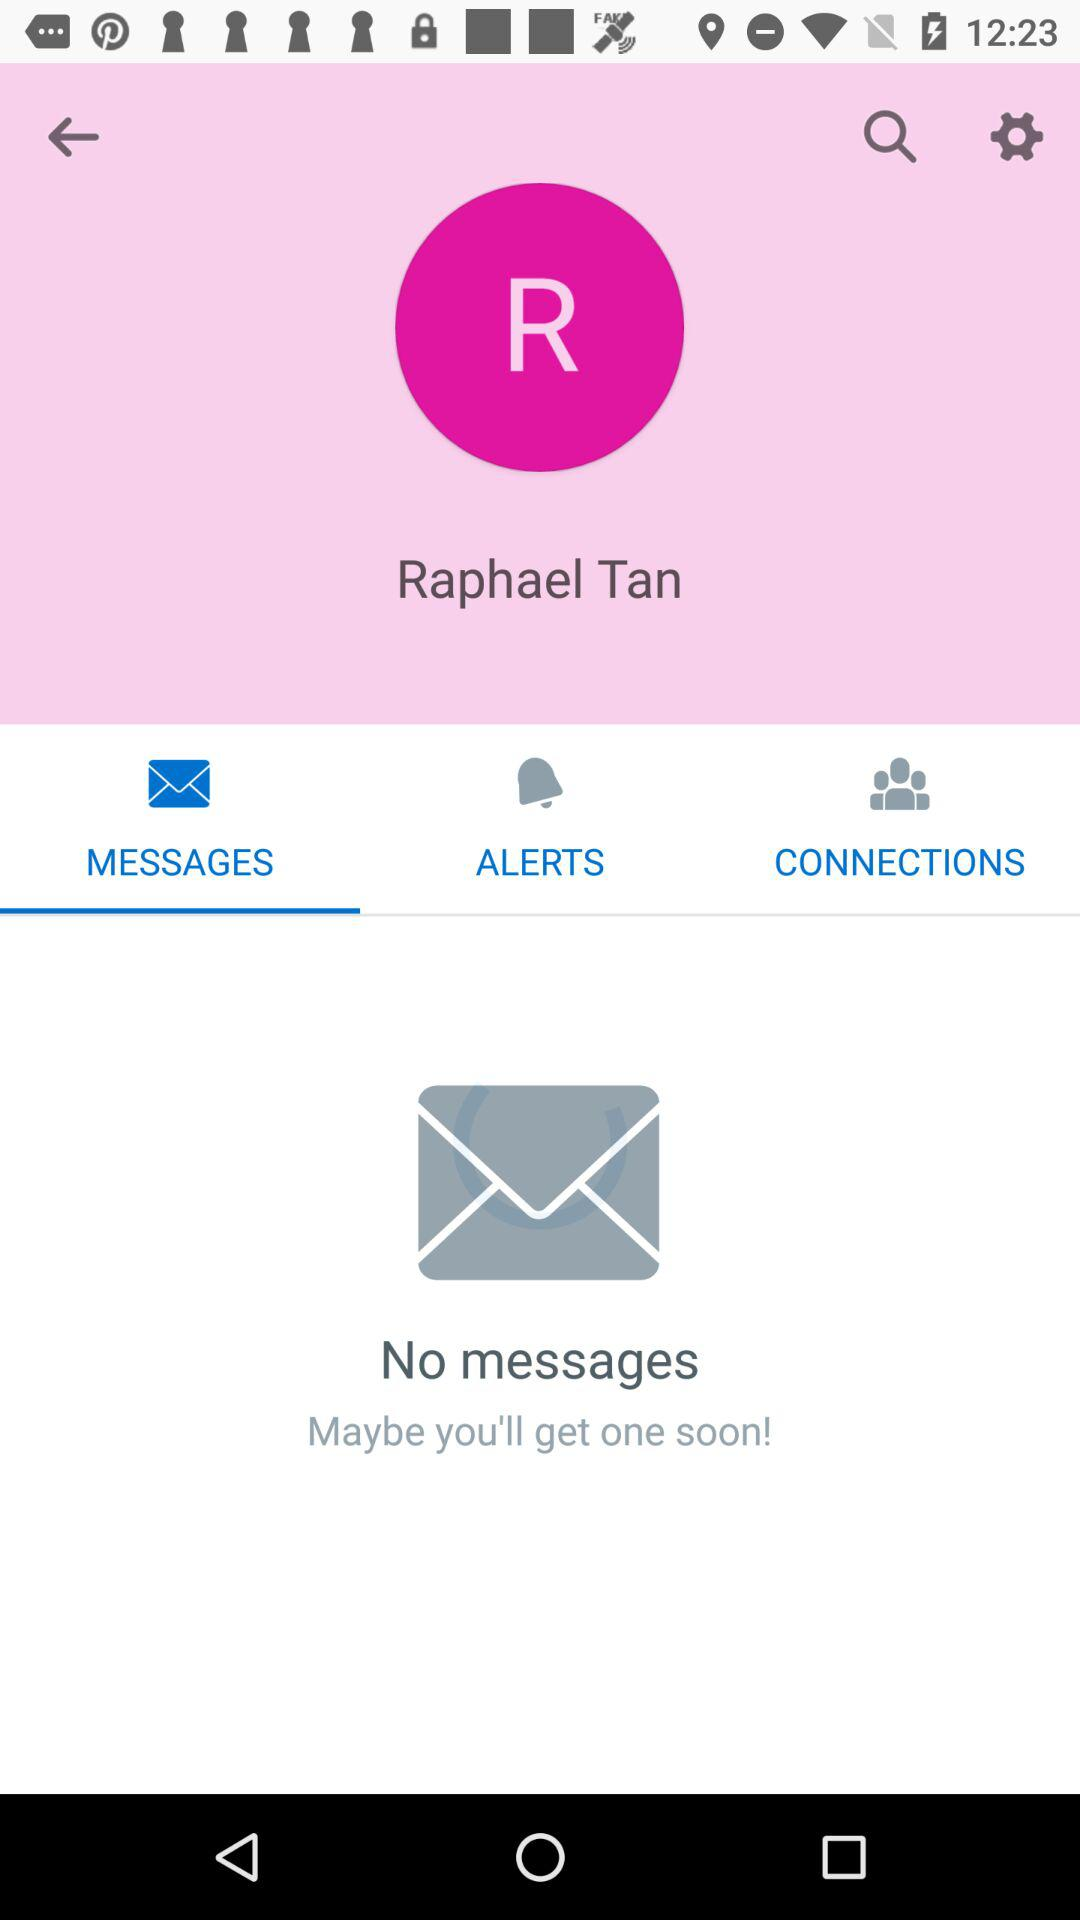Which is the selected tab? The selected tab is "MESSAGES". 